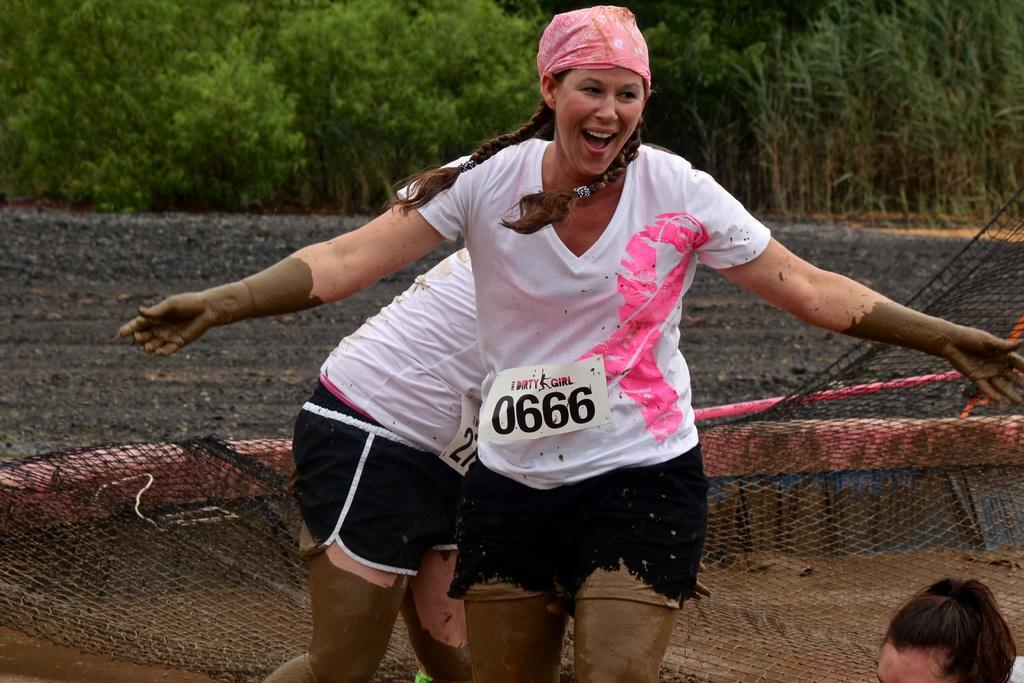<image>
Create a compact narrative representing the image presented. Woman wearing a sign that says 0666 and wearing a pink bandana. 